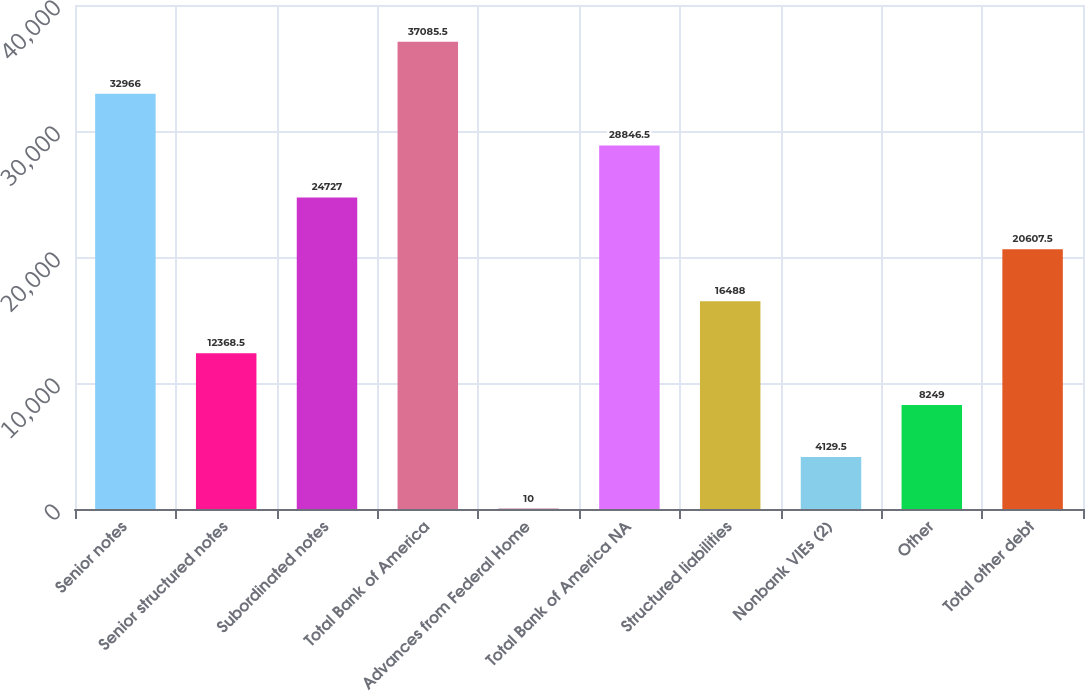Convert chart to OTSL. <chart><loc_0><loc_0><loc_500><loc_500><bar_chart><fcel>Senior notes<fcel>Senior structured notes<fcel>Subordinated notes<fcel>Total Bank of America<fcel>Advances from Federal Home<fcel>Total Bank of America NA<fcel>Structured liabilities<fcel>Nonbank VIEs (2)<fcel>Other<fcel>Total other debt<nl><fcel>32966<fcel>12368.5<fcel>24727<fcel>37085.5<fcel>10<fcel>28846.5<fcel>16488<fcel>4129.5<fcel>8249<fcel>20607.5<nl></chart> 